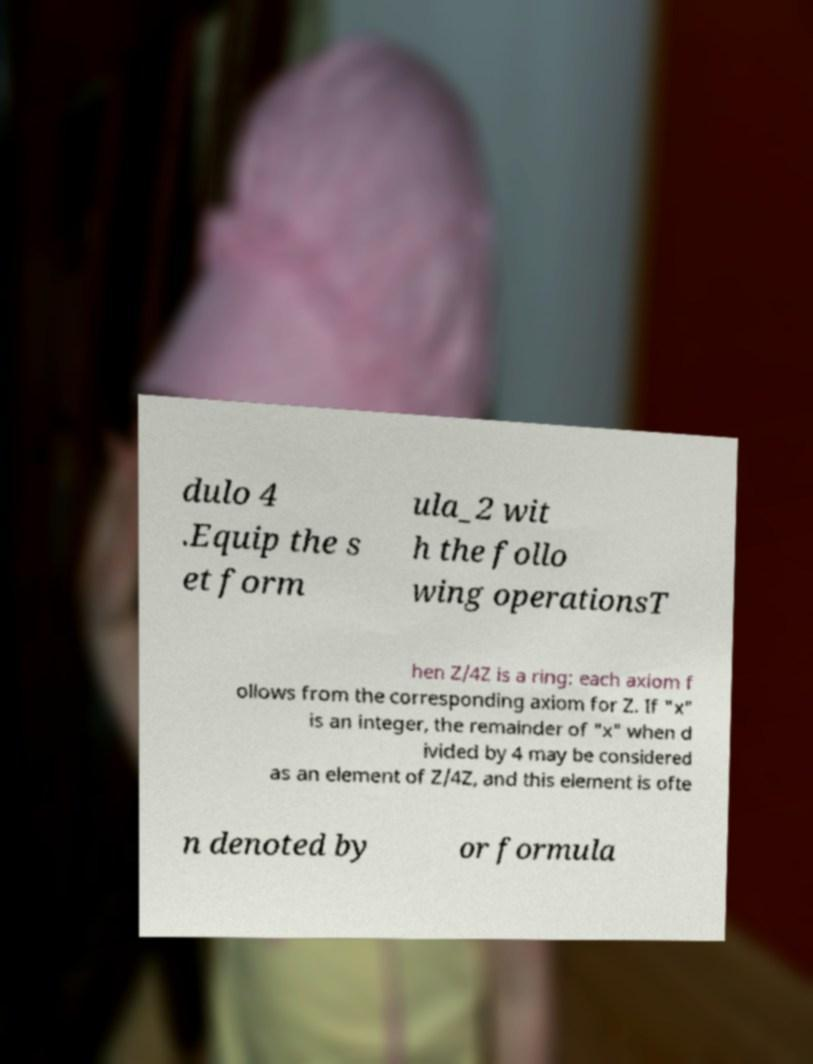What messages or text are displayed in this image? I need them in a readable, typed format. dulo 4 .Equip the s et form ula_2 wit h the follo wing operationsT hen Z/4Z is a ring: each axiom f ollows from the corresponding axiom for Z. If "x" is an integer, the remainder of "x" when d ivided by 4 may be considered as an element of Z/4Z, and this element is ofte n denoted by or formula 